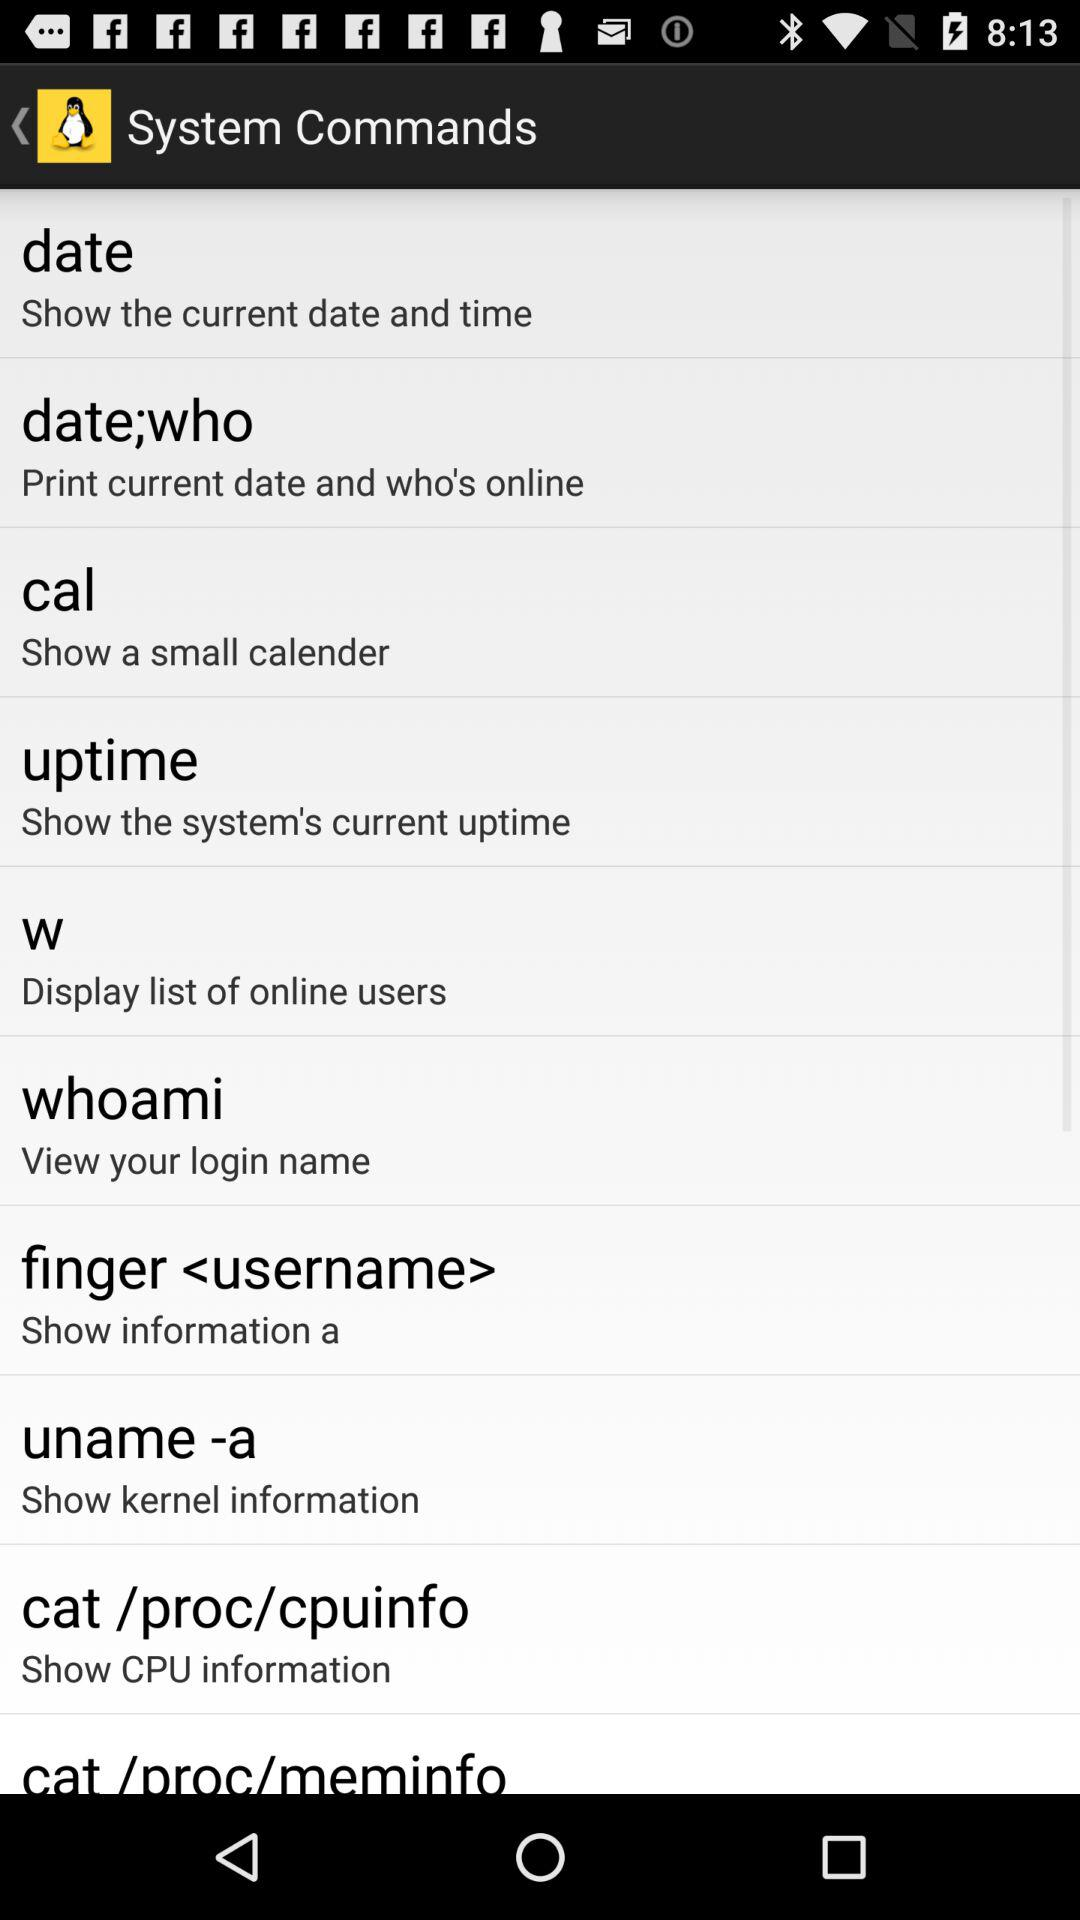What is the setting available in system commands?
When the provided information is insufficient, respond with <no answer>. <no answer> 